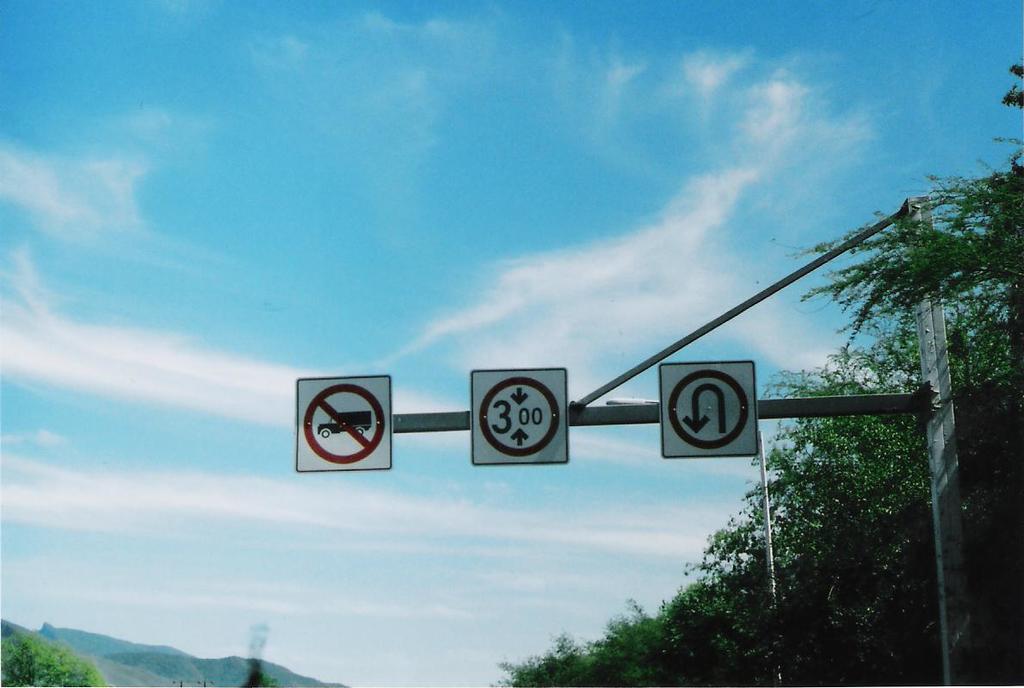What is the number on the sig?
Provide a short and direct response. 300. 